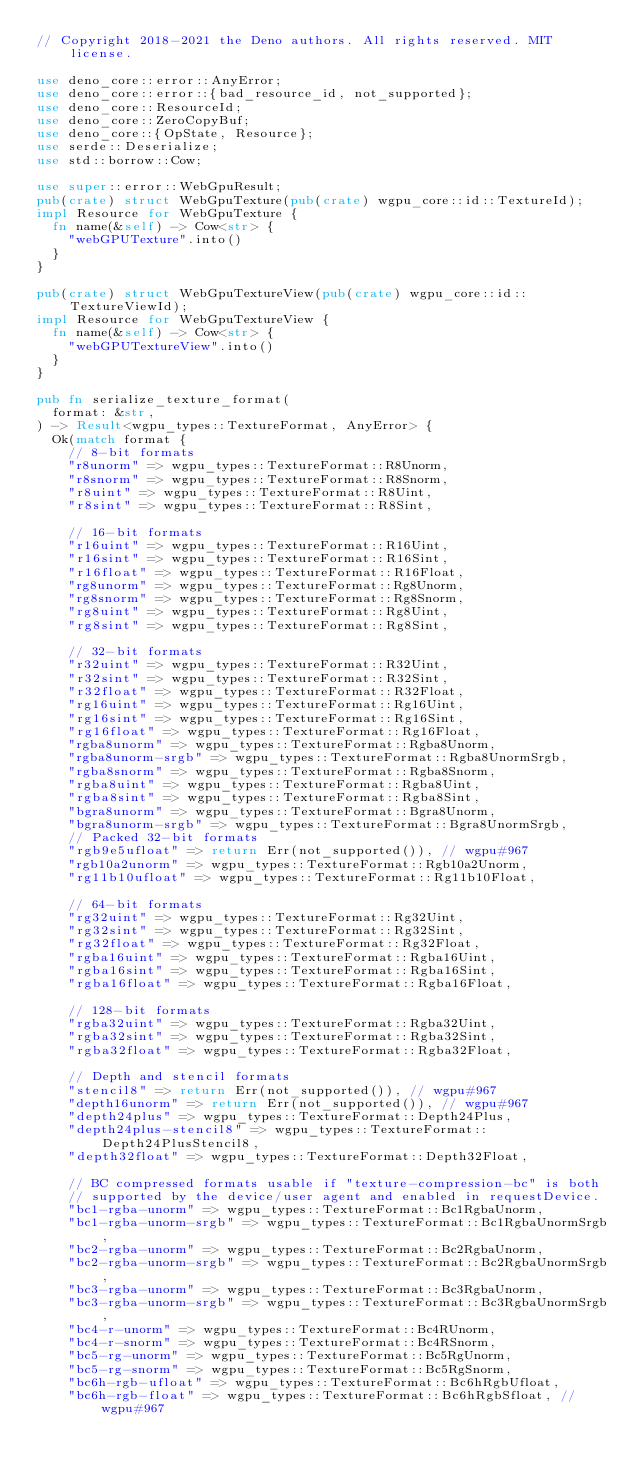Convert code to text. <code><loc_0><loc_0><loc_500><loc_500><_Rust_>// Copyright 2018-2021 the Deno authors. All rights reserved. MIT license.

use deno_core::error::AnyError;
use deno_core::error::{bad_resource_id, not_supported};
use deno_core::ResourceId;
use deno_core::ZeroCopyBuf;
use deno_core::{OpState, Resource};
use serde::Deserialize;
use std::borrow::Cow;

use super::error::WebGpuResult;
pub(crate) struct WebGpuTexture(pub(crate) wgpu_core::id::TextureId);
impl Resource for WebGpuTexture {
  fn name(&self) -> Cow<str> {
    "webGPUTexture".into()
  }
}

pub(crate) struct WebGpuTextureView(pub(crate) wgpu_core::id::TextureViewId);
impl Resource for WebGpuTextureView {
  fn name(&self) -> Cow<str> {
    "webGPUTextureView".into()
  }
}

pub fn serialize_texture_format(
  format: &str,
) -> Result<wgpu_types::TextureFormat, AnyError> {
  Ok(match format {
    // 8-bit formats
    "r8unorm" => wgpu_types::TextureFormat::R8Unorm,
    "r8snorm" => wgpu_types::TextureFormat::R8Snorm,
    "r8uint" => wgpu_types::TextureFormat::R8Uint,
    "r8sint" => wgpu_types::TextureFormat::R8Sint,

    // 16-bit formats
    "r16uint" => wgpu_types::TextureFormat::R16Uint,
    "r16sint" => wgpu_types::TextureFormat::R16Sint,
    "r16float" => wgpu_types::TextureFormat::R16Float,
    "rg8unorm" => wgpu_types::TextureFormat::Rg8Unorm,
    "rg8snorm" => wgpu_types::TextureFormat::Rg8Snorm,
    "rg8uint" => wgpu_types::TextureFormat::Rg8Uint,
    "rg8sint" => wgpu_types::TextureFormat::Rg8Sint,

    // 32-bit formats
    "r32uint" => wgpu_types::TextureFormat::R32Uint,
    "r32sint" => wgpu_types::TextureFormat::R32Sint,
    "r32float" => wgpu_types::TextureFormat::R32Float,
    "rg16uint" => wgpu_types::TextureFormat::Rg16Uint,
    "rg16sint" => wgpu_types::TextureFormat::Rg16Sint,
    "rg16float" => wgpu_types::TextureFormat::Rg16Float,
    "rgba8unorm" => wgpu_types::TextureFormat::Rgba8Unorm,
    "rgba8unorm-srgb" => wgpu_types::TextureFormat::Rgba8UnormSrgb,
    "rgba8snorm" => wgpu_types::TextureFormat::Rgba8Snorm,
    "rgba8uint" => wgpu_types::TextureFormat::Rgba8Uint,
    "rgba8sint" => wgpu_types::TextureFormat::Rgba8Sint,
    "bgra8unorm" => wgpu_types::TextureFormat::Bgra8Unorm,
    "bgra8unorm-srgb" => wgpu_types::TextureFormat::Bgra8UnormSrgb,
    // Packed 32-bit formats
    "rgb9e5ufloat" => return Err(not_supported()), // wgpu#967
    "rgb10a2unorm" => wgpu_types::TextureFormat::Rgb10a2Unorm,
    "rg11b10ufloat" => wgpu_types::TextureFormat::Rg11b10Float,

    // 64-bit formats
    "rg32uint" => wgpu_types::TextureFormat::Rg32Uint,
    "rg32sint" => wgpu_types::TextureFormat::Rg32Sint,
    "rg32float" => wgpu_types::TextureFormat::Rg32Float,
    "rgba16uint" => wgpu_types::TextureFormat::Rgba16Uint,
    "rgba16sint" => wgpu_types::TextureFormat::Rgba16Sint,
    "rgba16float" => wgpu_types::TextureFormat::Rgba16Float,

    // 128-bit formats
    "rgba32uint" => wgpu_types::TextureFormat::Rgba32Uint,
    "rgba32sint" => wgpu_types::TextureFormat::Rgba32Sint,
    "rgba32float" => wgpu_types::TextureFormat::Rgba32Float,

    // Depth and stencil formats
    "stencil8" => return Err(not_supported()), // wgpu#967
    "depth16unorm" => return Err(not_supported()), // wgpu#967
    "depth24plus" => wgpu_types::TextureFormat::Depth24Plus,
    "depth24plus-stencil8" => wgpu_types::TextureFormat::Depth24PlusStencil8,
    "depth32float" => wgpu_types::TextureFormat::Depth32Float,

    // BC compressed formats usable if "texture-compression-bc" is both
    // supported by the device/user agent and enabled in requestDevice.
    "bc1-rgba-unorm" => wgpu_types::TextureFormat::Bc1RgbaUnorm,
    "bc1-rgba-unorm-srgb" => wgpu_types::TextureFormat::Bc1RgbaUnormSrgb,
    "bc2-rgba-unorm" => wgpu_types::TextureFormat::Bc2RgbaUnorm,
    "bc2-rgba-unorm-srgb" => wgpu_types::TextureFormat::Bc2RgbaUnormSrgb,
    "bc3-rgba-unorm" => wgpu_types::TextureFormat::Bc3RgbaUnorm,
    "bc3-rgba-unorm-srgb" => wgpu_types::TextureFormat::Bc3RgbaUnormSrgb,
    "bc4-r-unorm" => wgpu_types::TextureFormat::Bc4RUnorm,
    "bc4-r-snorm" => wgpu_types::TextureFormat::Bc4RSnorm,
    "bc5-rg-unorm" => wgpu_types::TextureFormat::Bc5RgUnorm,
    "bc5-rg-snorm" => wgpu_types::TextureFormat::Bc5RgSnorm,
    "bc6h-rgb-ufloat" => wgpu_types::TextureFormat::Bc6hRgbUfloat,
    "bc6h-rgb-float" => wgpu_types::TextureFormat::Bc6hRgbSfloat, // wgpu#967</code> 